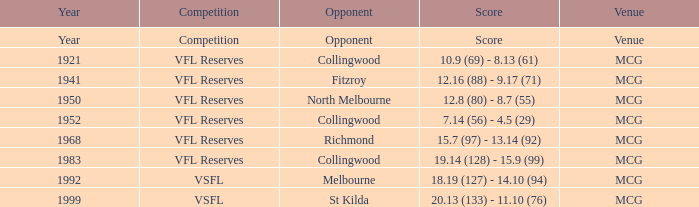5 (29)? MCG. 